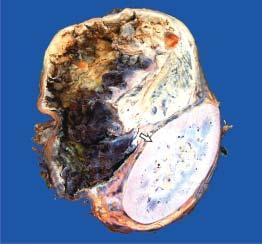does the alveoli and respiratory bronchioles surrounding the coal macule show compressed kidney at the lower end while the upper end shows a large spherical tumour separate from the kidney?
Answer the question using a single word or phrase. No 